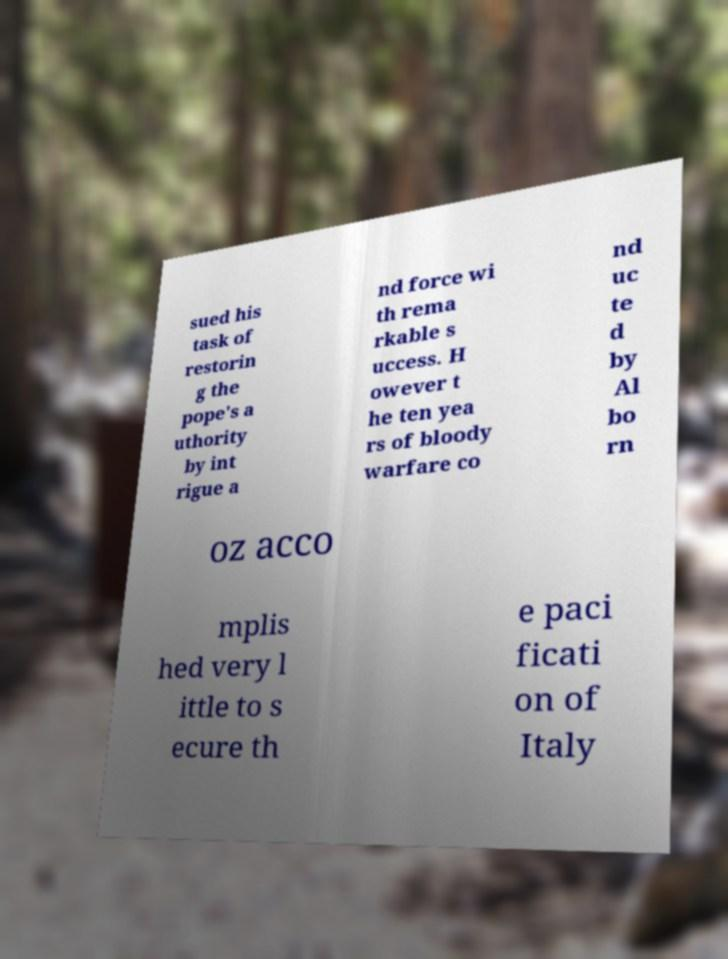Please identify and transcribe the text found in this image. sued his task of restorin g the pope's a uthority by int rigue a nd force wi th rema rkable s uccess. H owever t he ten yea rs of bloody warfare co nd uc te d by Al bo rn oz acco mplis hed very l ittle to s ecure th e paci ficati on of Italy 